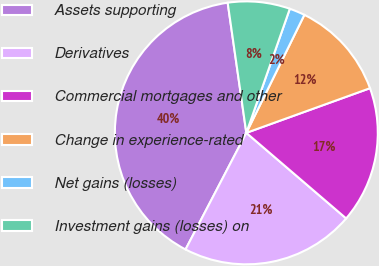<chart> <loc_0><loc_0><loc_500><loc_500><pie_chart><fcel>Assets supporting<fcel>Derivatives<fcel>Commercial mortgages and other<fcel>Change in experience-rated<fcel>Net gains (losses)<fcel>Investment gains (losses) on<nl><fcel>40.08%<fcel>21.37%<fcel>16.79%<fcel>12.21%<fcel>1.91%<fcel>7.63%<nl></chart> 